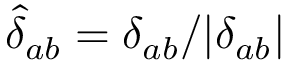Convert formula to latex. <formula><loc_0><loc_0><loc_500><loc_500>\hat { \delta } _ { a b } = \delta _ { a b } / | \delta _ { a b } |</formula> 